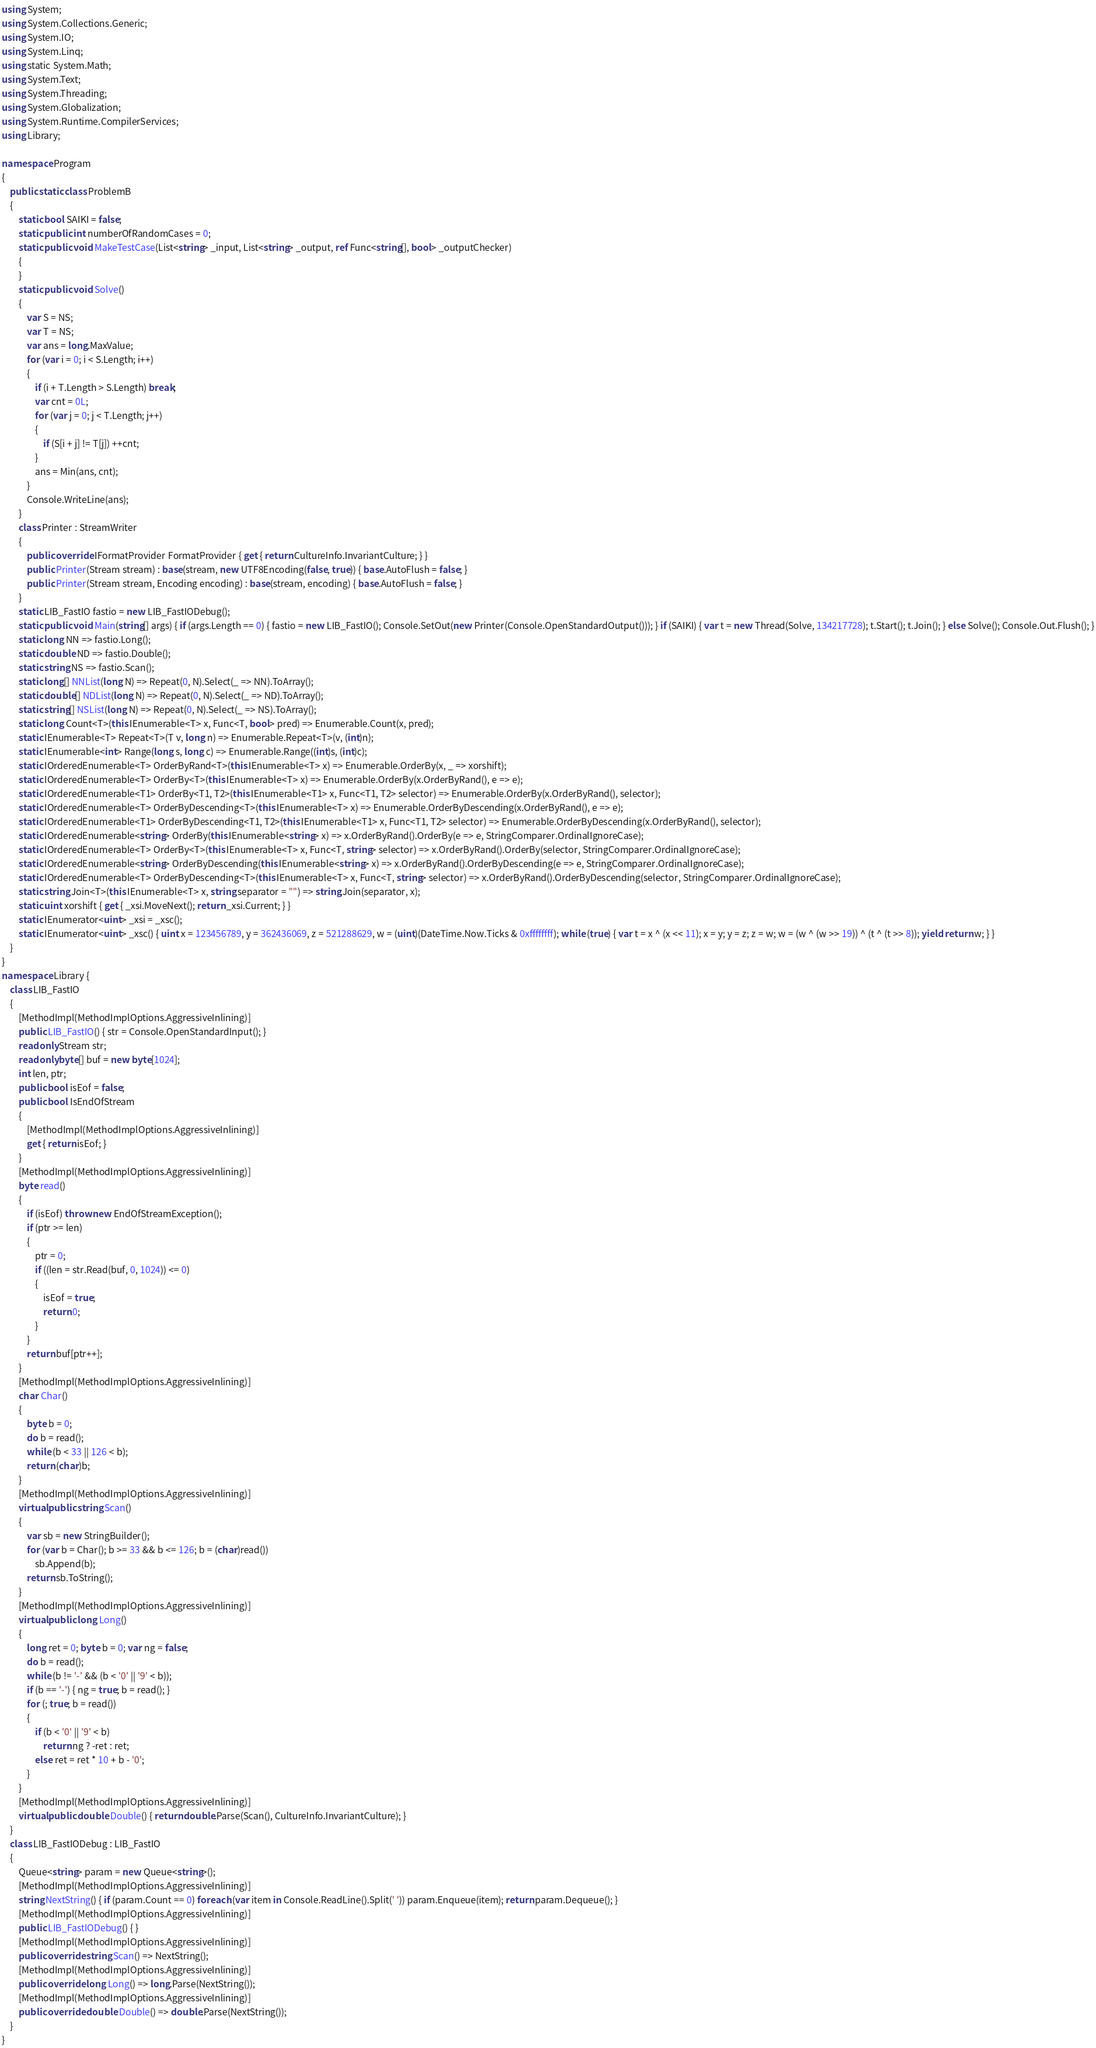Convert code to text. <code><loc_0><loc_0><loc_500><loc_500><_C#_>using System;
using System.Collections.Generic;
using System.IO;
using System.Linq;
using static System.Math;
using System.Text;
using System.Threading;
using System.Globalization;
using System.Runtime.CompilerServices;
using Library;

namespace Program
{
    public static class ProblemB
    {
        static bool SAIKI = false;
        static public int numberOfRandomCases = 0;
        static public void MakeTestCase(List<string> _input, List<string> _output, ref Func<string[], bool> _outputChecker)
        {
        }
        static public void Solve()
        {
            var S = NS;
            var T = NS;
            var ans = long.MaxValue;
            for (var i = 0; i < S.Length; i++)
            {
                if (i + T.Length > S.Length) break;
                var cnt = 0L;
                for (var j = 0; j < T.Length; j++)
                {
                    if (S[i + j] != T[j]) ++cnt;
                }
                ans = Min(ans, cnt);
            }
            Console.WriteLine(ans);
        }
        class Printer : StreamWriter
        {
            public override IFormatProvider FormatProvider { get { return CultureInfo.InvariantCulture; } }
            public Printer(Stream stream) : base(stream, new UTF8Encoding(false, true)) { base.AutoFlush = false; }
            public Printer(Stream stream, Encoding encoding) : base(stream, encoding) { base.AutoFlush = false; }
        }
        static LIB_FastIO fastio = new LIB_FastIODebug();
        static public void Main(string[] args) { if (args.Length == 0) { fastio = new LIB_FastIO(); Console.SetOut(new Printer(Console.OpenStandardOutput())); } if (SAIKI) { var t = new Thread(Solve, 134217728); t.Start(); t.Join(); } else Solve(); Console.Out.Flush(); }
        static long NN => fastio.Long();
        static double ND => fastio.Double();
        static string NS => fastio.Scan();
        static long[] NNList(long N) => Repeat(0, N).Select(_ => NN).ToArray();
        static double[] NDList(long N) => Repeat(0, N).Select(_ => ND).ToArray();
        static string[] NSList(long N) => Repeat(0, N).Select(_ => NS).ToArray();
        static long Count<T>(this IEnumerable<T> x, Func<T, bool> pred) => Enumerable.Count(x, pred);
        static IEnumerable<T> Repeat<T>(T v, long n) => Enumerable.Repeat<T>(v, (int)n);
        static IEnumerable<int> Range(long s, long c) => Enumerable.Range((int)s, (int)c);
        static IOrderedEnumerable<T> OrderByRand<T>(this IEnumerable<T> x) => Enumerable.OrderBy(x, _ => xorshift);
        static IOrderedEnumerable<T> OrderBy<T>(this IEnumerable<T> x) => Enumerable.OrderBy(x.OrderByRand(), e => e);
        static IOrderedEnumerable<T1> OrderBy<T1, T2>(this IEnumerable<T1> x, Func<T1, T2> selector) => Enumerable.OrderBy(x.OrderByRand(), selector);
        static IOrderedEnumerable<T> OrderByDescending<T>(this IEnumerable<T> x) => Enumerable.OrderByDescending(x.OrderByRand(), e => e);
        static IOrderedEnumerable<T1> OrderByDescending<T1, T2>(this IEnumerable<T1> x, Func<T1, T2> selector) => Enumerable.OrderByDescending(x.OrderByRand(), selector);
        static IOrderedEnumerable<string> OrderBy(this IEnumerable<string> x) => x.OrderByRand().OrderBy(e => e, StringComparer.OrdinalIgnoreCase);
        static IOrderedEnumerable<T> OrderBy<T>(this IEnumerable<T> x, Func<T, string> selector) => x.OrderByRand().OrderBy(selector, StringComparer.OrdinalIgnoreCase);
        static IOrderedEnumerable<string> OrderByDescending(this IEnumerable<string> x) => x.OrderByRand().OrderByDescending(e => e, StringComparer.OrdinalIgnoreCase);
        static IOrderedEnumerable<T> OrderByDescending<T>(this IEnumerable<T> x, Func<T, string> selector) => x.OrderByRand().OrderByDescending(selector, StringComparer.OrdinalIgnoreCase);
        static string Join<T>(this IEnumerable<T> x, string separator = "") => string.Join(separator, x);
        static uint xorshift { get { _xsi.MoveNext(); return _xsi.Current; } }
        static IEnumerator<uint> _xsi = _xsc();
        static IEnumerator<uint> _xsc() { uint x = 123456789, y = 362436069, z = 521288629, w = (uint)(DateTime.Now.Ticks & 0xffffffff); while (true) { var t = x ^ (x << 11); x = y; y = z; z = w; w = (w ^ (w >> 19)) ^ (t ^ (t >> 8)); yield return w; } }
    }
}
namespace Library {
    class LIB_FastIO
    {
        [MethodImpl(MethodImplOptions.AggressiveInlining)]
        public LIB_FastIO() { str = Console.OpenStandardInput(); }
        readonly Stream str;
        readonly byte[] buf = new byte[1024];
        int len, ptr;
        public bool isEof = false;
        public bool IsEndOfStream
        {
            [MethodImpl(MethodImplOptions.AggressiveInlining)]
            get { return isEof; }
        }
        [MethodImpl(MethodImplOptions.AggressiveInlining)]
        byte read()
        {
            if (isEof) throw new EndOfStreamException();
            if (ptr >= len)
            {
                ptr = 0;
                if ((len = str.Read(buf, 0, 1024)) <= 0)
                {
                    isEof = true;
                    return 0;
                }
            }
            return buf[ptr++];
        }
        [MethodImpl(MethodImplOptions.AggressiveInlining)]
        char Char()
        {
            byte b = 0;
            do b = read();
            while (b < 33 || 126 < b);
            return (char)b;
        }
        [MethodImpl(MethodImplOptions.AggressiveInlining)]
        virtual public string Scan()
        {
            var sb = new StringBuilder();
            for (var b = Char(); b >= 33 && b <= 126; b = (char)read())
                sb.Append(b);
            return sb.ToString();
        }
        [MethodImpl(MethodImplOptions.AggressiveInlining)]
        virtual public long Long()
        {
            long ret = 0; byte b = 0; var ng = false;
            do b = read();
            while (b != '-' && (b < '0' || '9' < b));
            if (b == '-') { ng = true; b = read(); }
            for (; true; b = read())
            {
                if (b < '0' || '9' < b)
                    return ng ? -ret : ret;
                else ret = ret * 10 + b - '0';
            }
        }
        [MethodImpl(MethodImplOptions.AggressiveInlining)]
        virtual public double Double() { return double.Parse(Scan(), CultureInfo.InvariantCulture); }
    }
    class LIB_FastIODebug : LIB_FastIO
    {
        Queue<string> param = new Queue<string>();
        [MethodImpl(MethodImplOptions.AggressiveInlining)]
        string NextString() { if (param.Count == 0) foreach (var item in Console.ReadLine().Split(' ')) param.Enqueue(item); return param.Dequeue(); }
        [MethodImpl(MethodImplOptions.AggressiveInlining)]
        public LIB_FastIODebug() { }
        [MethodImpl(MethodImplOptions.AggressiveInlining)]
        public override string Scan() => NextString();
        [MethodImpl(MethodImplOptions.AggressiveInlining)]
        public override long Long() => long.Parse(NextString());
        [MethodImpl(MethodImplOptions.AggressiveInlining)]
        public override double Double() => double.Parse(NextString());
    }
}
</code> 